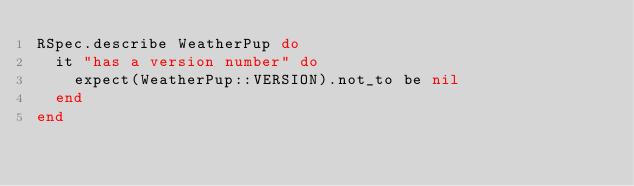<code> <loc_0><loc_0><loc_500><loc_500><_Ruby_>RSpec.describe WeatherPup do
  it "has a version number" do
    expect(WeatherPup::VERSION).not_to be nil
  end
end
</code> 